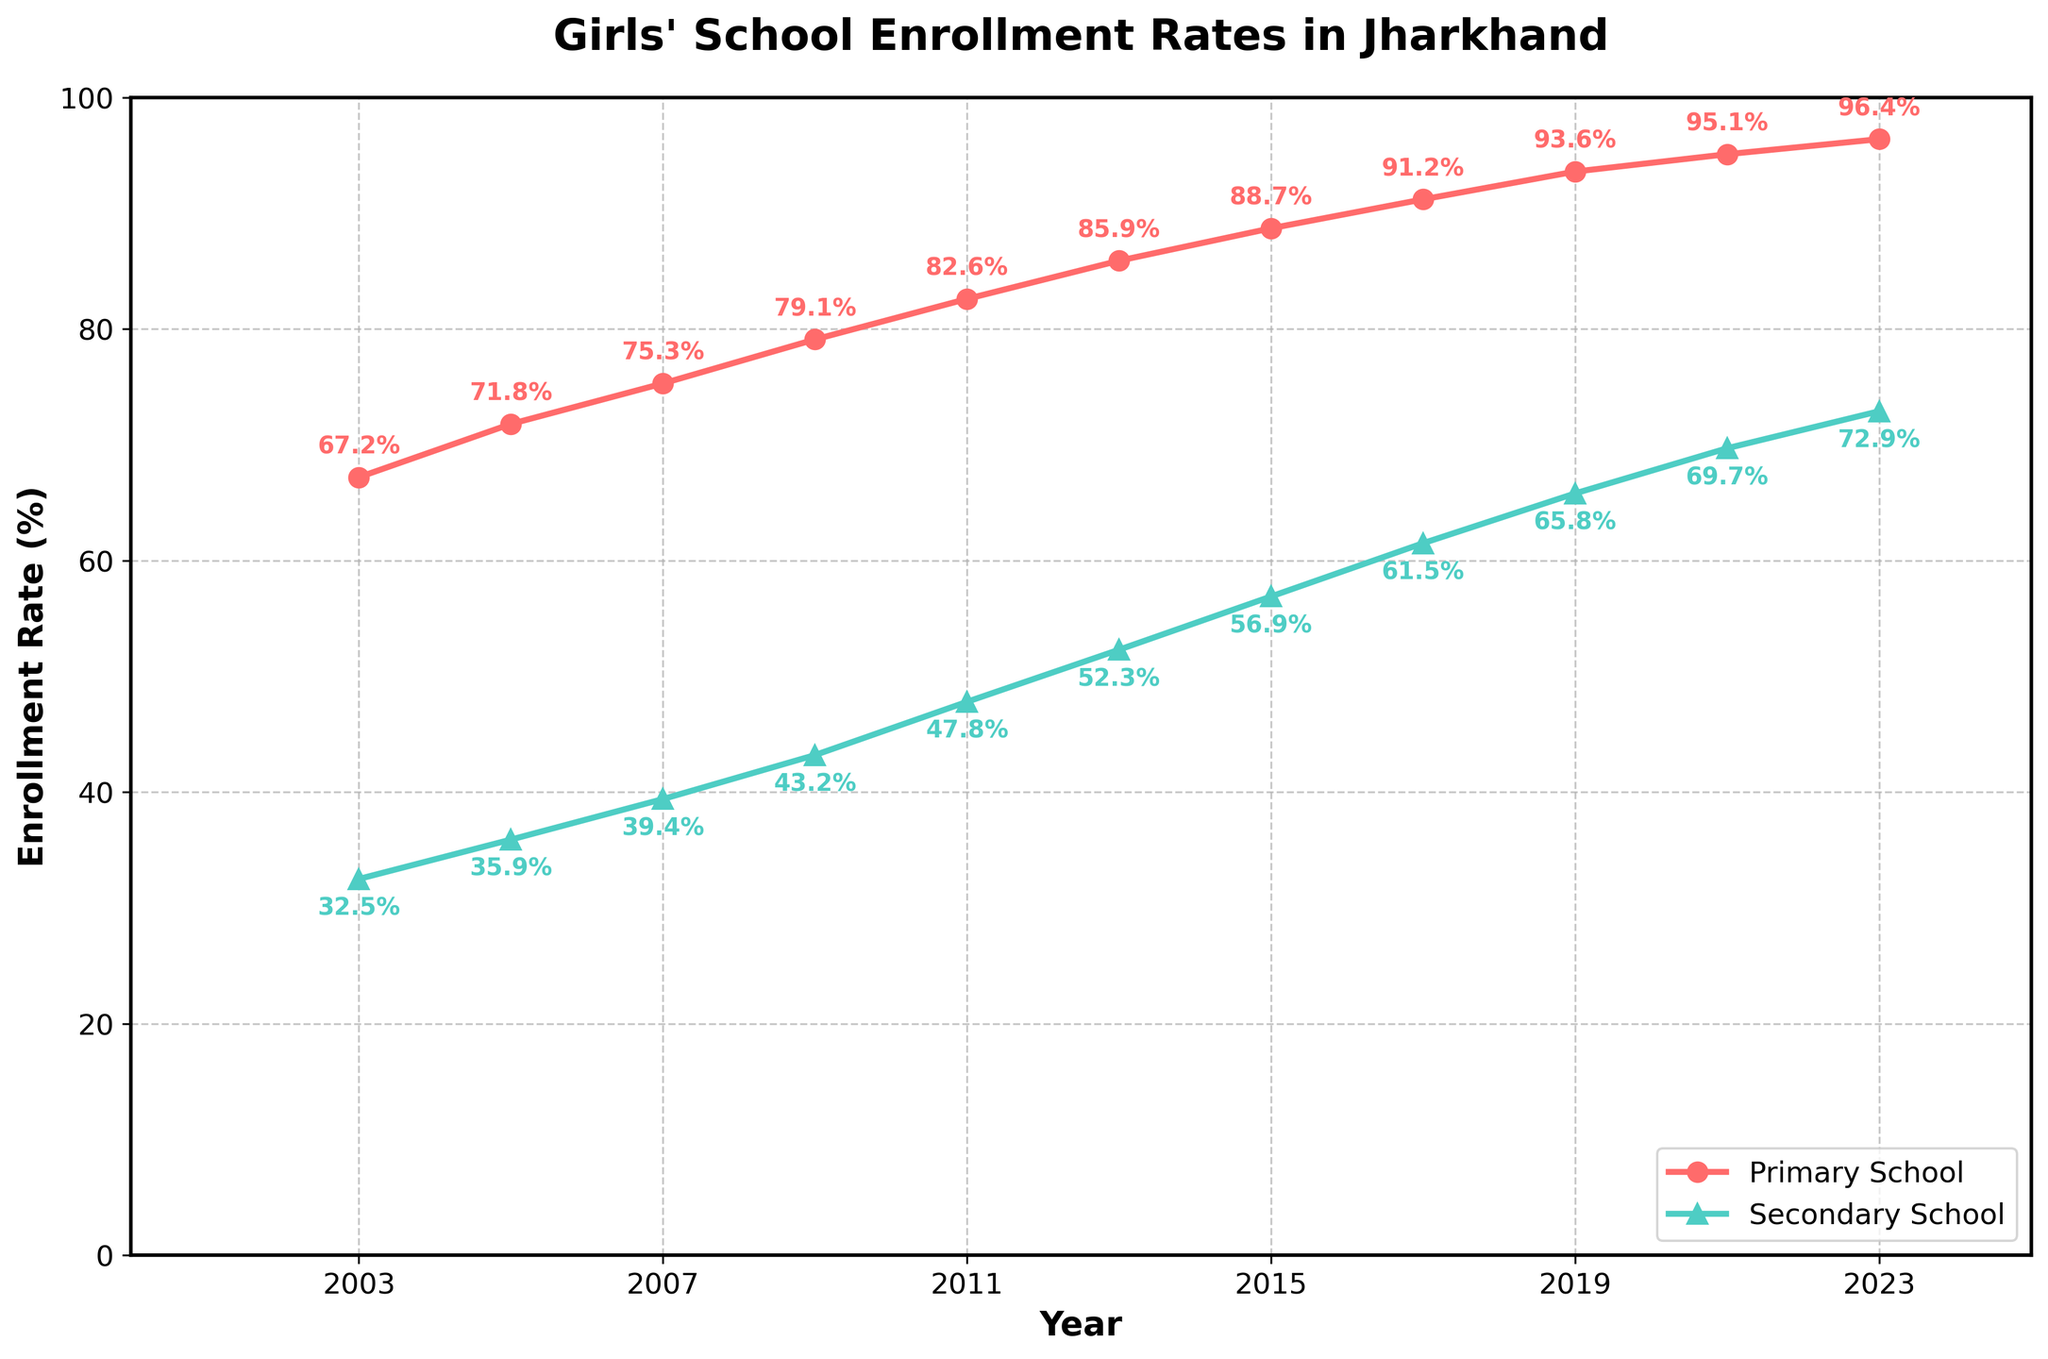What is the enrollment rate for primary schools in 2021? In 2021, the primary school enrollment rate is marked by a red line with a data point annotated with '95.1%' on the plot.
Answer: 95.1% Which year had a higher enrollment rate for primary school, 2005 or 2009? Compare the data points for the years 2005 and 2009 on the red line. The points are annotated as 71.8% for 2005 and 79.1% for 2009.
Answer: 2009 What is the difference in enrollment rates between primary and secondary schools in 2023? In 2023, the primary school rate is annotated as 96.4% and the secondary school rate as 72.9%. The difference is 96.4 - 72.9 = 23.5%.
Answer: 23.5% Is the enrollment rate of secondary schools in 2019 higher or lower compared to 2017? By how much? The secondary school enrollment rate is shown as 61.5% in 2017 and 65.8% in 2019. The difference is 65.8 - 61.5 = 4.3%.
Answer: Higher by 4.3% What is the average enrollment rate for primary schools from 2003 to 2023? Add the primary school enrollment percentages from 2003 (67.2), 2005 (71.8), 2007 (75.3), 2009 (79.1), 2011 (82.6), 2013 (85.9), 2015 (88.7), 2017 (91.2), 2019 (93.6), 2021 (95.1), and 2023 (96.4), then divide by 11. The average is (67.2 + 71.8 + 75.3 + 79.1 + 82.6 + 85.9 + 88.7 + 91.2 + 93.6 + 95.1 + 96.4) / 11 = 84.3%.
Answer: 84.3% By how much did the enrollment rates for secondary schools increase from 2003 to 2023? The secondary school rate in 2003 is 32.5% and in 2023 is 72.9%. The increase is 72.9 - 32.5 = 40.4%.
Answer: 40.4% In which year did the primary school enrollment rate exceed 90% for the first time? Look at the red line and find the year where the annotated percentage first passes 90%. This is in 2017, marked as 91.2%.
Answer: 2017 Does the plot show a consistent increase in both primary and secondary school enrollment rates over the years? Observing the trend lines for both primary (red) and secondary (green), they continuously rise from 2003 to 2023 without any decrease in any year.
Answer: Yes 